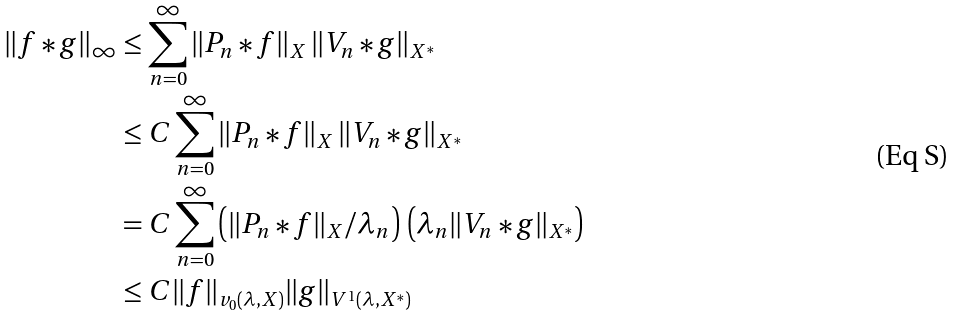<formula> <loc_0><loc_0><loc_500><loc_500>\| f * g \| _ { \infty } & \leq \sum _ { n = 0 } ^ { \infty } \| P _ { n } * f \| _ { X } \, \| V _ { n } * g \| _ { X ^ { \ast } } \\ & \leq C \sum _ { n = 0 } ^ { \infty } \| P _ { n } * f \| _ { X } \, \| V _ { n } * g \| _ { X ^ { \ast } } \\ & = C \sum _ { n = 0 } ^ { \infty } \left ( \| P _ { n } * f \| _ { X } / \lambda _ { n } \right ) \, \left ( \lambda _ { n } \| V _ { n } * g \| _ { X ^ { \ast } } \right ) \\ & \leq C \| f \| _ { v _ { 0 } ( \lambda , X ) } \| g \| _ { V ^ { 1 } ( \lambda , X ^ { \ast } ) }</formula> 